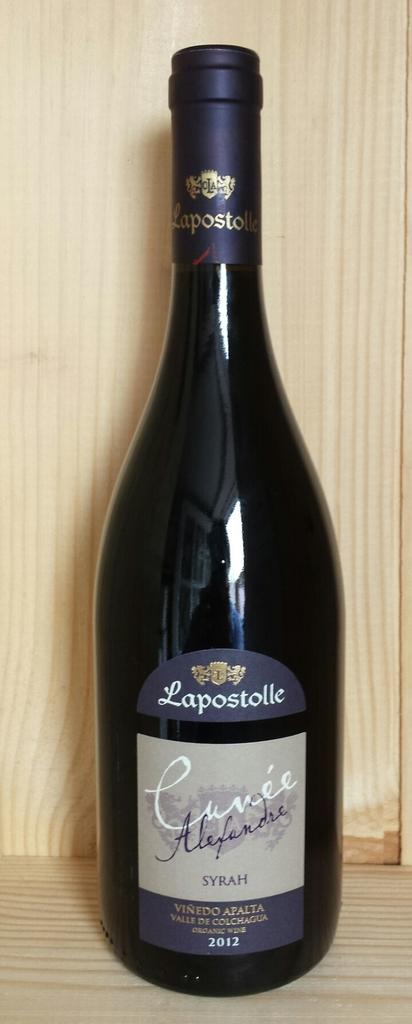What does the top label say?
Provide a succinct answer. Lapostolle. 